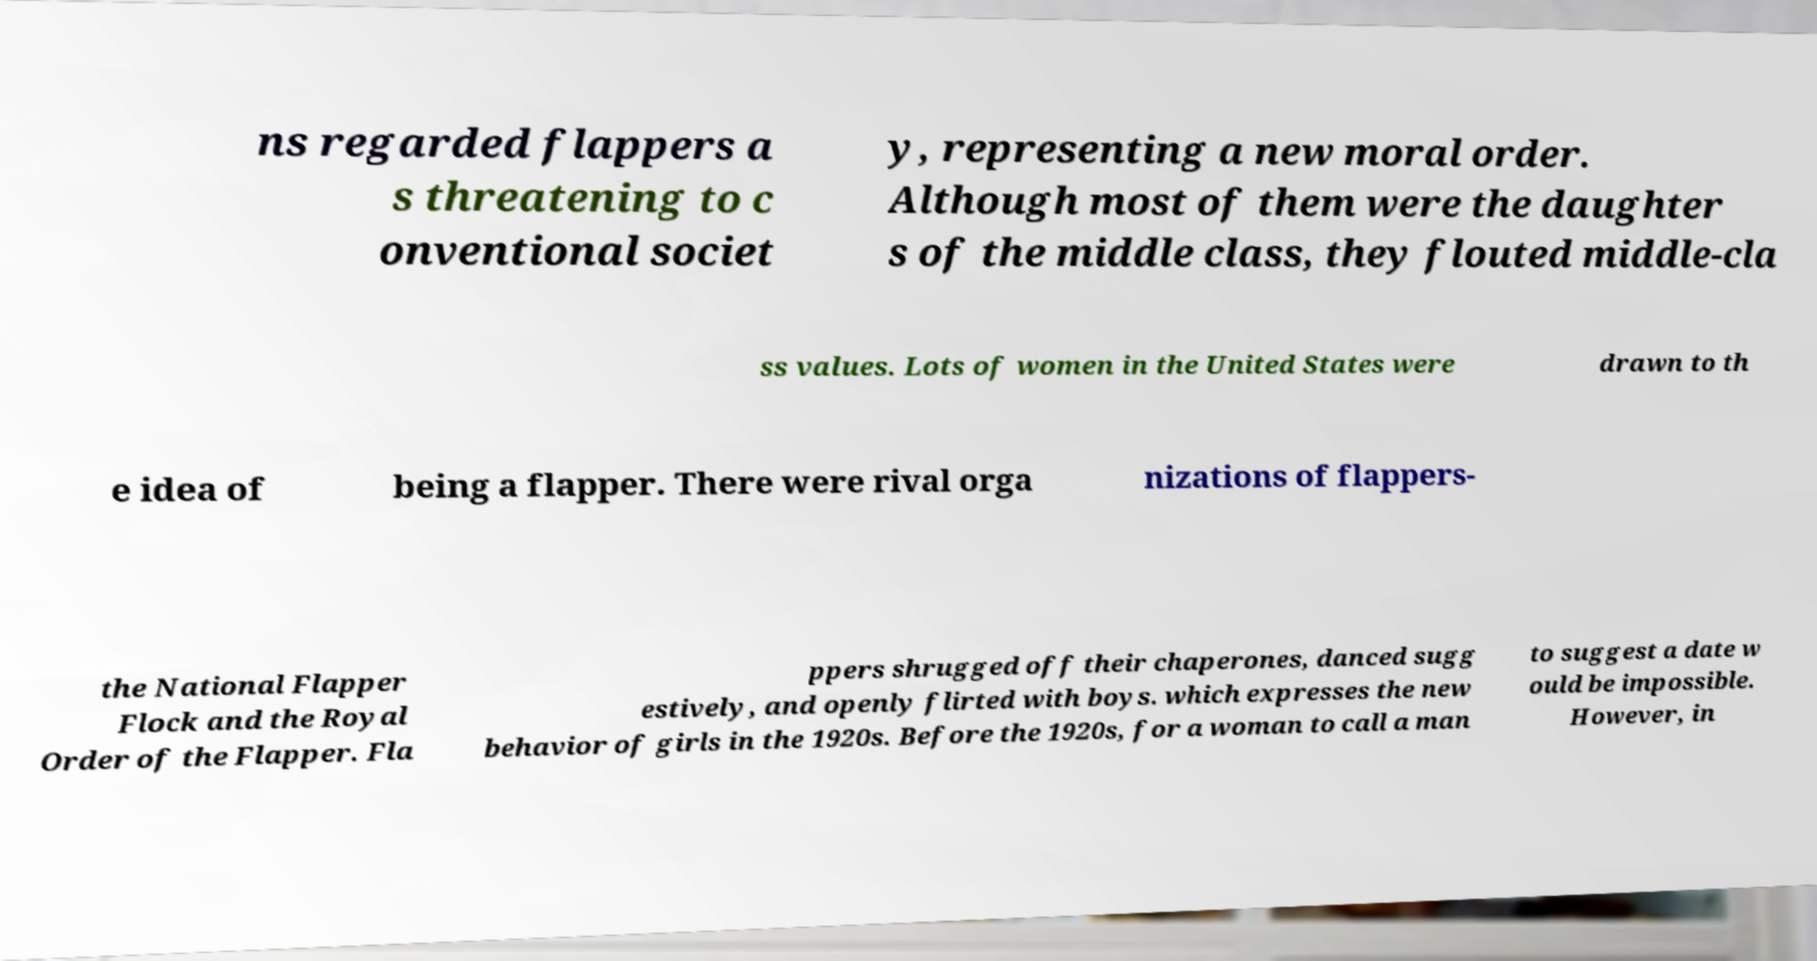There's text embedded in this image that I need extracted. Can you transcribe it verbatim? ns regarded flappers a s threatening to c onventional societ y, representing a new moral order. Although most of them were the daughter s of the middle class, they flouted middle-cla ss values. Lots of women in the United States were drawn to th e idea of being a flapper. There were rival orga nizations of flappers- the National Flapper Flock and the Royal Order of the Flapper. Fla ppers shrugged off their chaperones, danced sugg estively, and openly flirted with boys. which expresses the new behavior of girls in the 1920s. Before the 1920s, for a woman to call a man to suggest a date w ould be impossible. However, in 